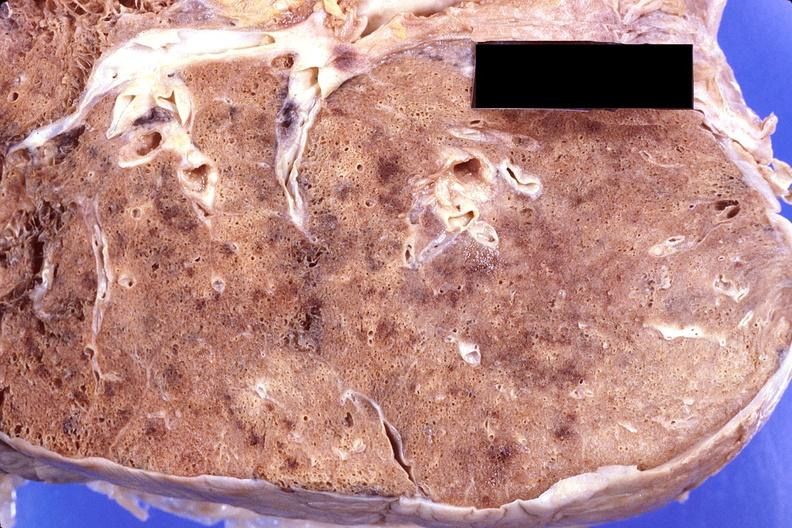s total effacement case present?
Answer the question using a single word or phrase. No 